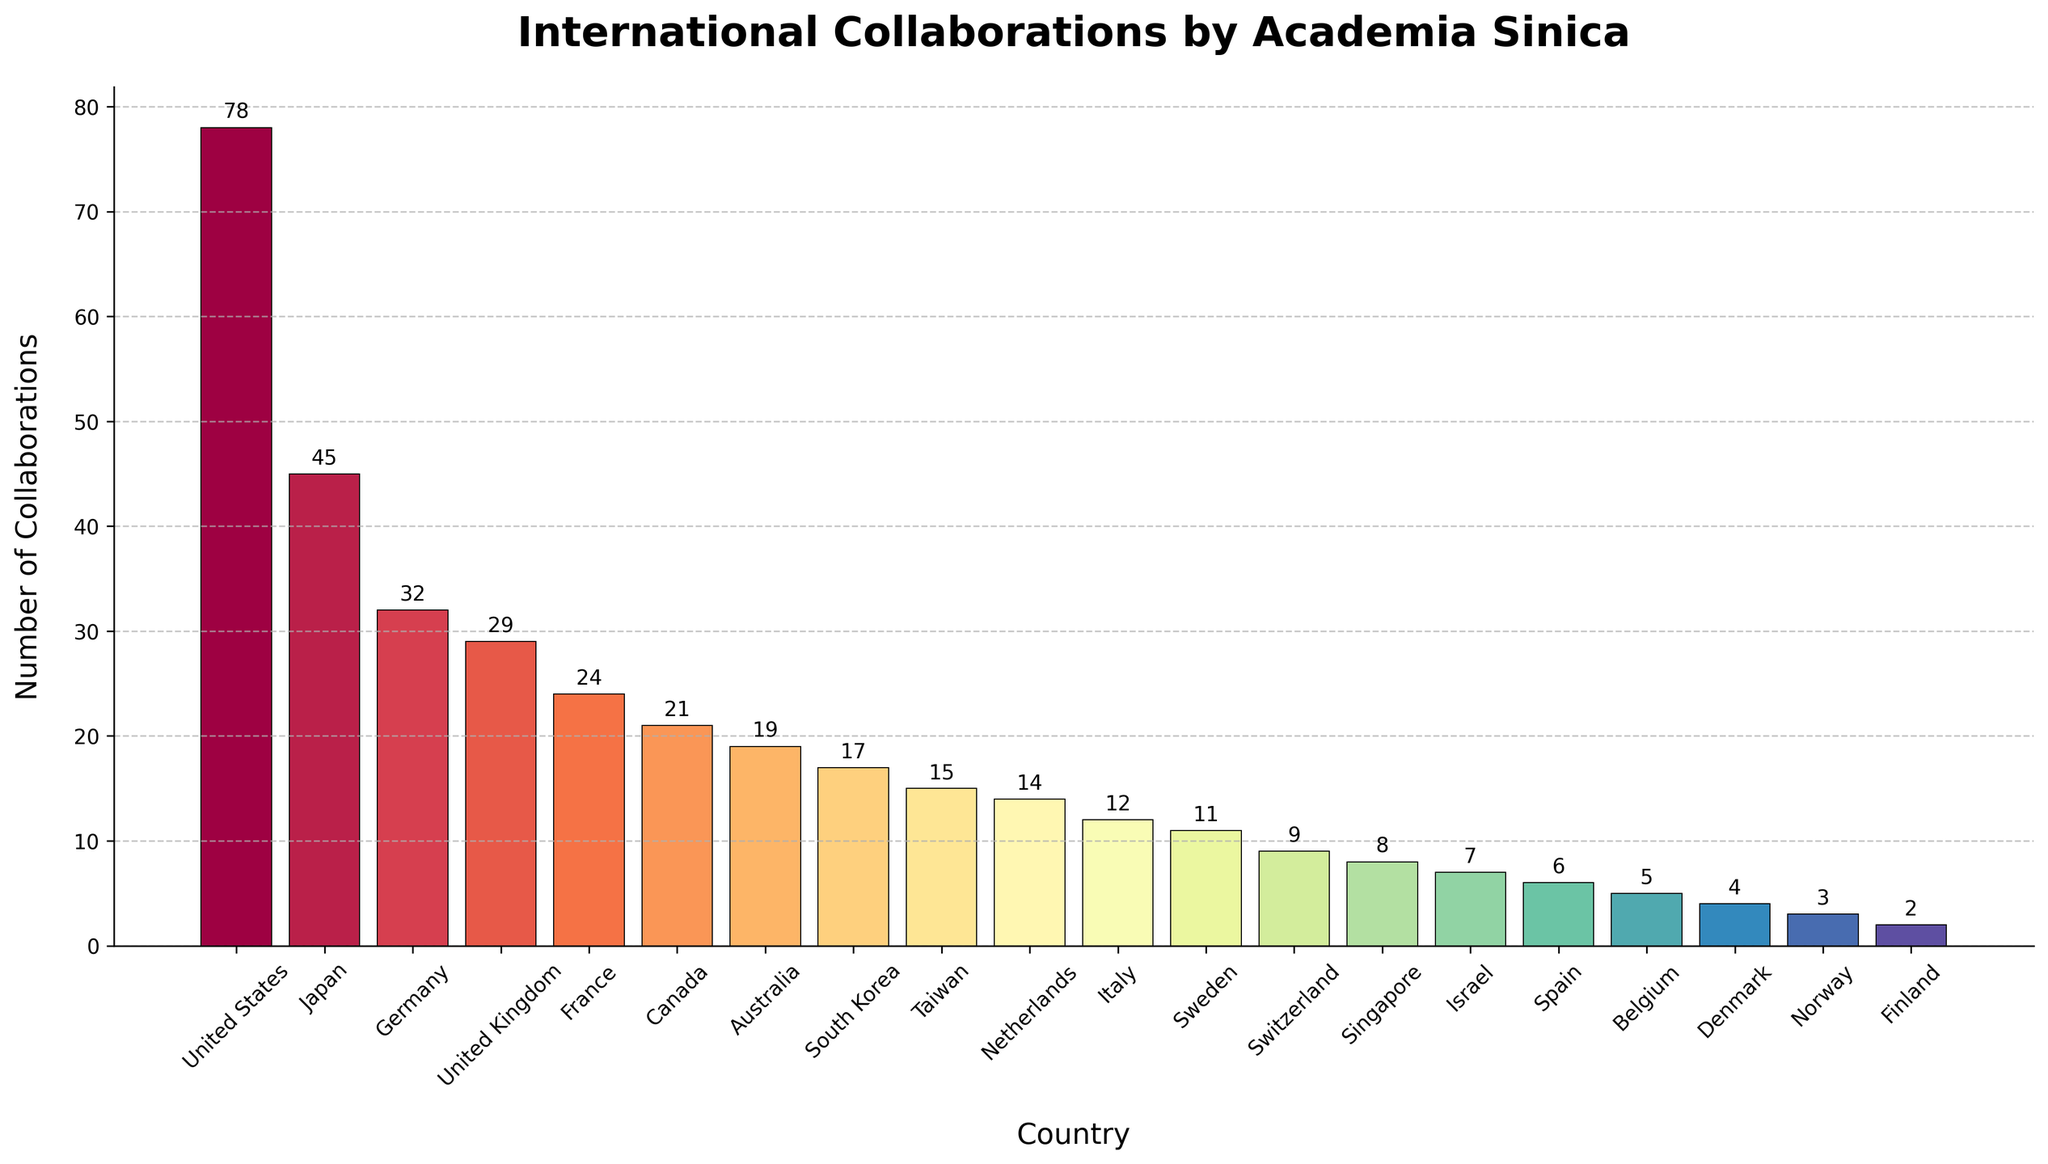What country has the highest number of collaborations with Academia Sinica? From the bar chart, the tallest bar represents the country with the highest number of collaborations. The United States has the highest bar.
Answer: United States How many more collaborations does Academia Sinica have with Japan compared to France? According to the figure, Japan has 45 collaborations and France has 24. The difference is 45 - 24 = 21.
Answer: 21 Which country has fewer collaborations with Academia Sinica: Germany or Canada? From the bar chart, Germany has 32 collaborations while Canada has 21. Therefore, Canada has fewer collaborations.
Answer: Canada What is the total number of collaborations Academia Sinica has with South Korea, Taiwan, and Singapore combined? According to the figure, South Korea has 17 collaborations, Taiwan has 15, and Singapore has 8. The total is 17 + 15 + 8 = 40.
Answer: 40 Identify the country with the second lowest number of collaborations with Academia Sinica. By examining the height of the bars, Finland has the lowest with 2 collaborations. The next smallest bar represents Norway with 3 collaborations.
Answer: Norway How many countries have more than 20 collaborations with Academia Sinica? Observing the heights of the bars, the countries with more than 20 collaborations are the United States, Japan, Germany, the United Kingdom, and France. This gives us a total of 5 countries.
Answer: 5 Compare the number of collaborations Academia Sinica has with the Netherlands and Australia. Which one is higher? From the bar chart, Australia has 19 collaborations while the Netherlands has 14. Thus, Australia has a higher number of collaborations.
Answer: Australia What is the average number of collaborations for the top 3 collaborating countries? The top 3 countries are the United States (78), Japan (45), and Germany (32). The average number of collaborations is (78 + 45 + 32) / 3 = 51.67.
Answer: 51.67 In terms of visual representation, which country has the bar colored with the most intense segment of the color map? The most intense color in the Spectral color map is usually associated with the highest value. The United States with 78 collaborations has the most intense color bar.
Answer: United States What is the difference in collaborations between the country with the median number of collaborations and the country with the lowest number of collaborations? There are 20 countries listed. The median position would be the 10th and 11th countries. The countries in the 10th and 11th positions are Netherlands (14) and Italy (12). The median value is the average of these: (14 + 12) / 2 = 13. The country with the lowest collaborations is Finland with 2. The difference is 13 - 2 = 11.
Answer: 11 